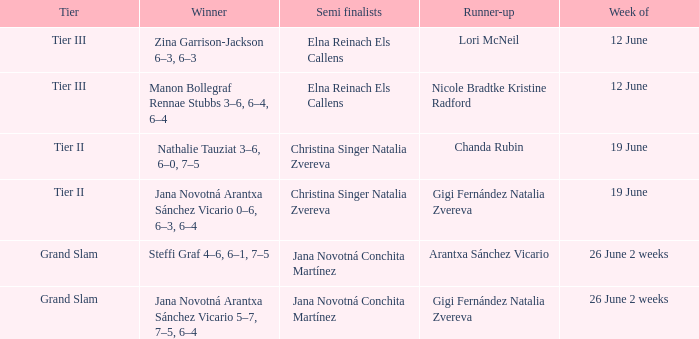In which week is the winner listed as Jana Novotná Arantxa Sánchez Vicario 5–7, 7–5, 6–4? 26 June 2 weeks. 